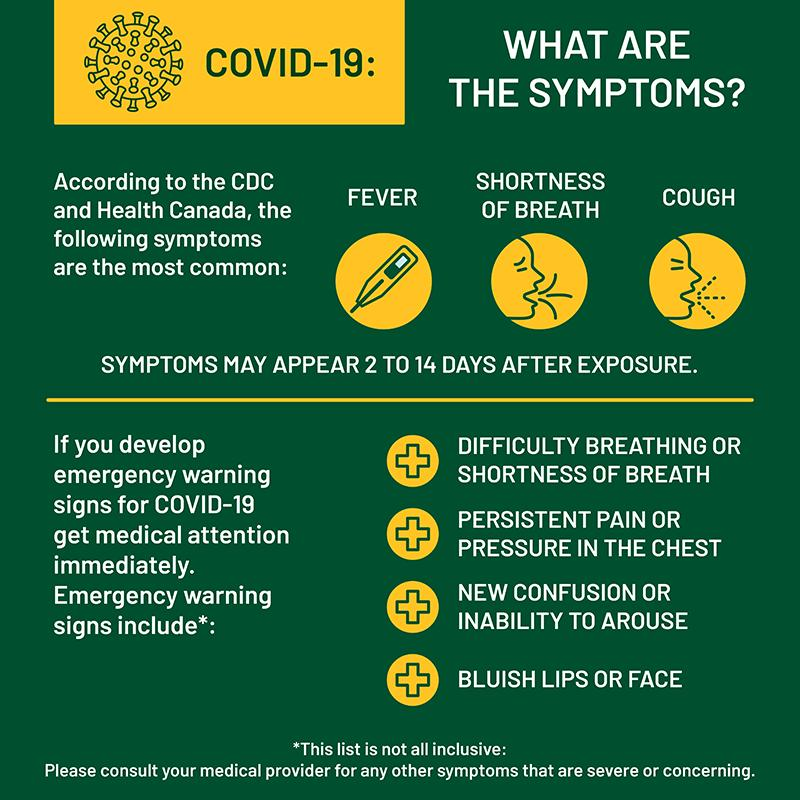Point out several critical features in this image. The symptoms of COVID-19, in addition to fever and cough, include shortness of breath. The incubation period for COVID-19 is typically 2 to 14 days, during which time an individual may not show any symptoms of the disease but may still spread the virus to others. 